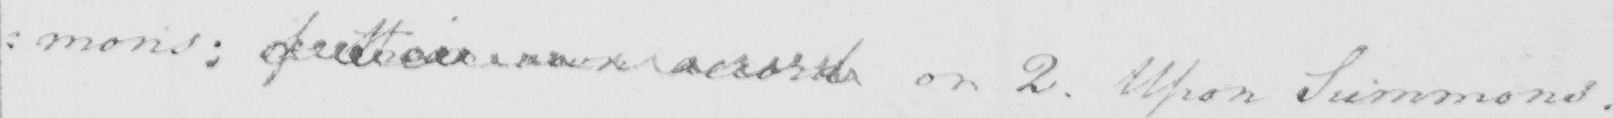What does this handwritten line say? : mons :  of  <gap/>  own accord or 2 . Upon Summons . 